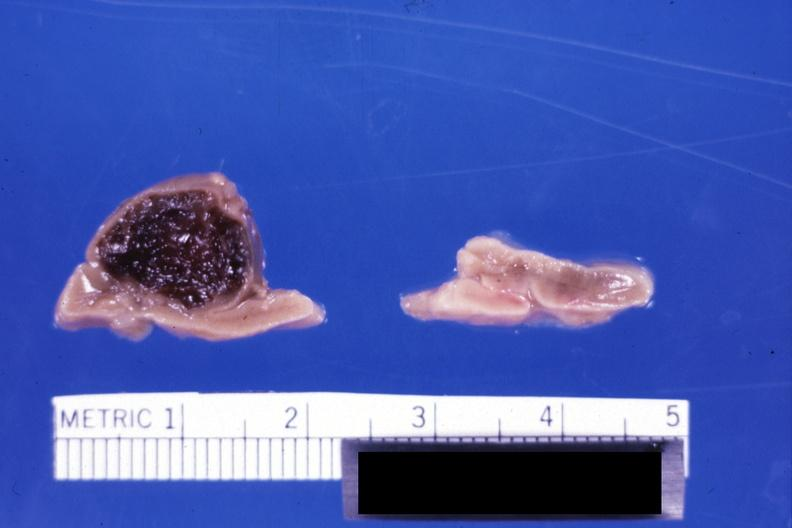s endocrine present?
Answer the question using a single word or phrase. Yes 